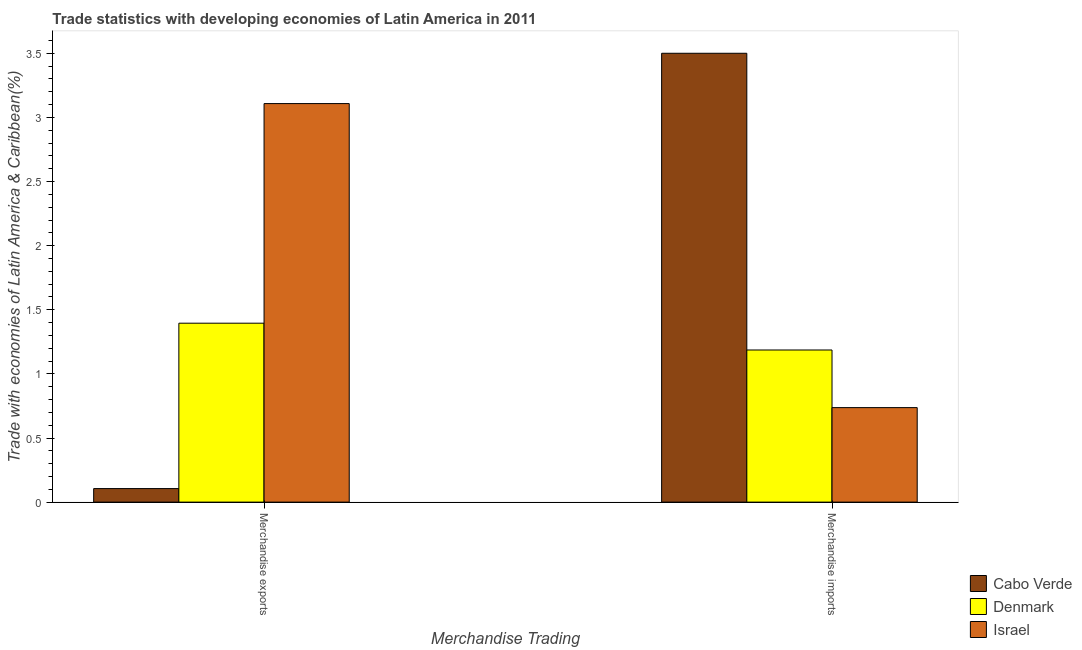How many groups of bars are there?
Ensure brevity in your answer.  2. What is the merchandise exports in Cabo Verde?
Keep it short and to the point. 0.11. Across all countries, what is the maximum merchandise imports?
Make the answer very short. 3.5. Across all countries, what is the minimum merchandise imports?
Keep it short and to the point. 0.74. In which country was the merchandise imports maximum?
Give a very brief answer. Cabo Verde. What is the total merchandise exports in the graph?
Offer a terse response. 4.61. What is the difference between the merchandise imports in Cabo Verde and that in Israel?
Give a very brief answer. 2.76. What is the difference between the merchandise exports in Israel and the merchandise imports in Cabo Verde?
Your answer should be compact. -0.39. What is the average merchandise imports per country?
Give a very brief answer. 1.81. What is the difference between the merchandise imports and merchandise exports in Denmark?
Your answer should be compact. -0.21. What is the ratio of the merchandise exports in Cabo Verde to that in Denmark?
Provide a succinct answer. 0.08. Are all the bars in the graph horizontal?
Provide a succinct answer. No. How many countries are there in the graph?
Your answer should be very brief. 3. What is the difference between two consecutive major ticks on the Y-axis?
Keep it short and to the point. 0.5. Are the values on the major ticks of Y-axis written in scientific E-notation?
Offer a very short reply. No. Does the graph contain any zero values?
Offer a very short reply. No. What is the title of the graph?
Offer a very short reply. Trade statistics with developing economies of Latin America in 2011. What is the label or title of the X-axis?
Give a very brief answer. Merchandise Trading. What is the label or title of the Y-axis?
Ensure brevity in your answer.  Trade with economies of Latin America & Caribbean(%). What is the Trade with economies of Latin America & Caribbean(%) of Cabo Verde in Merchandise exports?
Provide a short and direct response. 0.11. What is the Trade with economies of Latin America & Caribbean(%) in Denmark in Merchandise exports?
Your answer should be very brief. 1.4. What is the Trade with economies of Latin America & Caribbean(%) in Israel in Merchandise exports?
Make the answer very short. 3.11. What is the Trade with economies of Latin America & Caribbean(%) in Cabo Verde in Merchandise imports?
Your response must be concise. 3.5. What is the Trade with economies of Latin America & Caribbean(%) in Denmark in Merchandise imports?
Keep it short and to the point. 1.19. What is the Trade with economies of Latin America & Caribbean(%) of Israel in Merchandise imports?
Offer a terse response. 0.74. Across all Merchandise Trading, what is the maximum Trade with economies of Latin America & Caribbean(%) of Cabo Verde?
Your response must be concise. 3.5. Across all Merchandise Trading, what is the maximum Trade with economies of Latin America & Caribbean(%) in Denmark?
Give a very brief answer. 1.4. Across all Merchandise Trading, what is the maximum Trade with economies of Latin America & Caribbean(%) in Israel?
Your answer should be compact. 3.11. Across all Merchandise Trading, what is the minimum Trade with economies of Latin America & Caribbean(%) in Cabo Verde?
Provide a short and direct response. 0.11. Across all Merchandise Trading, what is the minimum Trade with economies of Latin America & Caribbean(%) of Denmark?
Offer a very short reply. 1.19. Across all Merchandise Trading, what is the minimum Trade with economies of Latin America & Caribbean(%) of Israel?
Provide a succinct answer. 0.74. What is the total Trade with economies of Latin America & Caribbean(%) in Cabo Verde in the graph?
Your response must be concise. 3.61. What is the total Trade with economies of Latin America & Caribbean(%) of Denmark in the graph?
Offer a very short reply. 2.58. What is the total Trade with economies of Latin America & Caribbean(%) of Israel in the graph?
Your response must be concise. 3.85. What is the difference between the Trade with economies of Latin America & Caribbean(%) in Cabo Verde in Merchandise exports and that in Merchandise imports?
Your answer should be compact. -3.4. What is the difference between the Trade with economies of Latin America & Caribbean(%) of Denmark in Merchandise exports and that in Merchandise imports?
Keep it short and to the point. 0.21. What is the difference between the Trade with economies of Latin America & Caribbean(%) in Israel in Merchandise exports and that in Merchandise imports?
Offer a terse response. 2.37. What is the difference between the Trade with economies of Latin America & Caribbean(%) of Cabo Verde in Merchandise exports and the Trade with economies of Latin America & Caribbean(%) of Denmark in Merchandise imports?
Provide a succinct answer. -1.08. What is the difference between the Trade with economies of Latin America & Caribbean(%) of Cabo Verde in Merchandise exports and the Trade with economies of Latin America & Caribbean(%) of Israel in Merchandise imports?
Ensure brevity in your answer.  -0.63. What is the difference between the Trade with economies of Latin America & Caribbean(%) in Denmark in Merchandise exports and the Trade with economies of Latin America & Caribbean(%) in Israel in Merchandise imports?
Offer a very short reply. 0.66. What is the average Trade with economies of Latin America & Caribbean(%) in Cabo Verde per Merchandise Trading?
Offer a terse response. 1.8. What is the average Trade with economies of Latin America & Caribbean(%) in Denmark per Merchandise Trading?
Ensure brevity in your answer.  1.29. What is the average Trade with economies of Latin America & Caribbean(%) of Israel per Merchandise Trading?
Offer a very short reply. 1.92. What is the difference between the Trade with economies of Latin America & Caribbean(%) of Cabo Verde and Trade with economies of Latin America & Caribbean(%) of Denmark in Merchandise exports?
Ensure brevity in your answer.  -1.29. What is the difference between the Trade with economies of Latin America & Caribbean(%) of Cabo Verde and Trade with economies of Latin America & Caribbean(%) of Israel in Merchandise exports?
Your response must be concise. -3. What is the difference between the Trade with economies of Latin America & Caribbean(%) in Denmark and Trade with economies of Latin America & Caribbean(%) in Israel in Merchandise exports?
Provide a succinct answer. -1.71. What is the difference between the Trade with economies of Latin America & Caribbean(%) in Cabo Verde and Trade with economies of Latin America & Caribbean(%) in Denmark in Merchandise imports?
Your answer should be very brief. 2.31. What is the difference between the Trade with economies of Latin America & Caribbean(%) in Cabo Verde and Trade with economies of Latin America & Caribbean(%) in Israel in Merchandise imports?
Provide a short and direct response. 2.76. What is the difference between the Trade with economies of Latin America & Caribbean(%) of Denmark and Trade with economies of Latin America & Caribbean(%) of Israel in Merchandise imports?
Your answer should be compact. 0.45. What is the ratio of the Trade with economies of Latin America & Caribbean(%) in Cabo Verde in Merchandise exports to that in Merchandise imports?
Provide a short and direct response. 0.03. What is the ratio of the Trade with economies of Latin America & Caribbean(%) in Denmark in Merchandise exports to that in Merchandise imports?
Your answer should be compact. 1.18. What is the ratio of the Trade with economies of Latin America & Caribbean(%) in Israel in Merchandise exports to that in Merchandise imports?
Give a very brief answer. 4.22. What is the difference between the highest and the second highest Trade with economies of Latin America & Caribbean(%) of Cabo Verde?
Offer a very short reply. 3.4. What is the difference between the highest and the second highest Trade with economies of Latin America & Caribbean(%) of Denmark?
Provide a succinct answer. 0.21. What is the difference between the highest and the second highest Trade with economies of Latin America & Caribbean(%) in Israel?
Your answer should be compact. 2.37. What is the difference between the highest and the lowest Trade with economies of Latin America & Caribbean(%) in Cabo Verde?
Provide a short and direct response. 3.4. What is the difference between the highest and the lowest Trade with economies of Latin America & Caribbean(%) in Denmark?
Offer a very short reply. 0.21. What is the difference between the highest and the lowest Trade with economies of Latin America & Caribbean(%) of Israel?
Provide a succinct answer. 2.37. 